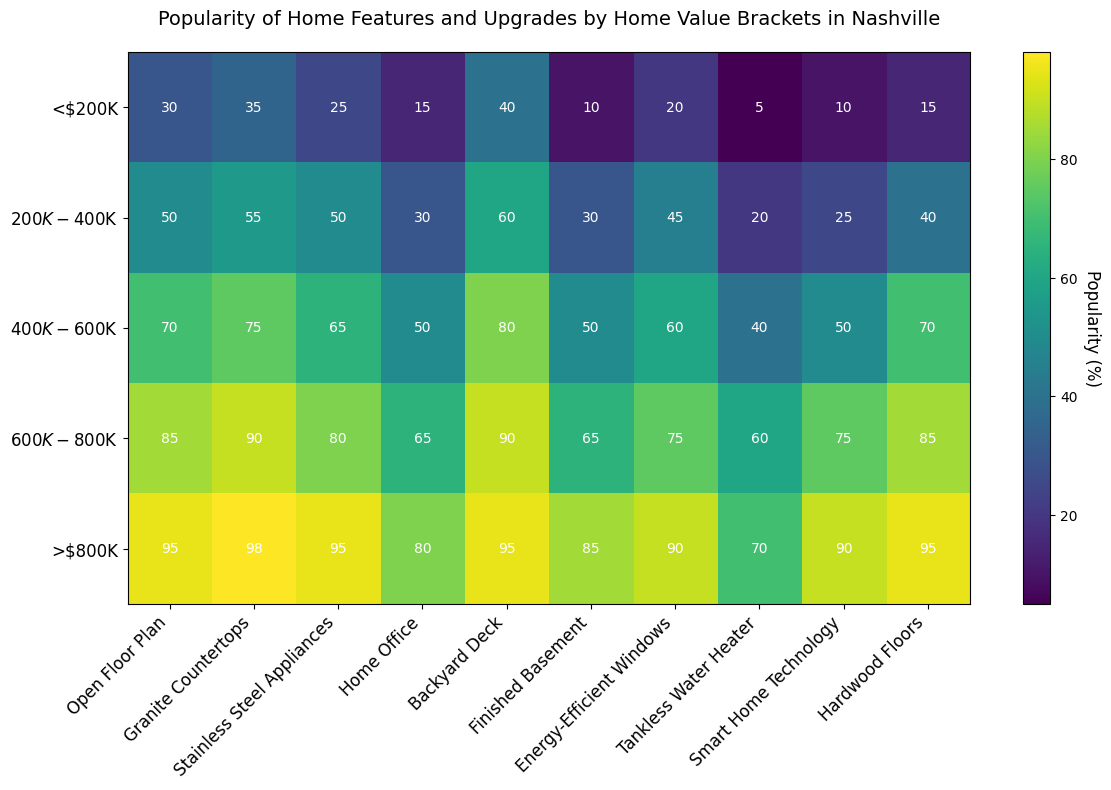Which home feature is most popular in homes valued at above $800K? The popularity values for each feature in the >$800K bracket are shown as percentages. Granite countertops have a value of 98%, which is the highest in this bracket.
Answer: Granite Countertops Which home feature has the least popularity in homes valued at $200K-$400K? Look at the <200K-$400K> row and identify the smallest percentage, which is 20% for Tankless Water Heater.
Answer: Tankless Water Heater What is the average popularity of Energy-Efficient Windows across all home value brackets? Add the percentages for Energy-Efficient Windows (20 + 45 + 60 + 75 + 90) which equals 290, and then divide by 5.
Answer: 58% Is the popularity of Smart Home Technology in the <$200K bracket greater than the popularity of a Home Office in the $200K-$400K bracket? Compare 10% (Smart Home Technology, <$200K>) with 30% (Home Office, $200K-$400K). 10% is less than 30%.
Answer: No Comparing homes in the $400K-$600K and $600K-$800K brackets, which home feature shows the biggest increase in popularity? Subtract the $400K-$600K values from the $600K-$800K values for each feature. The feature with the maximum difference is Smart Home Technology, which increased from 50 to 75, a difference of 25.
Answer: Smart Home Technology Is the popularity of Hardwood Floors in homes valued at >$800K equal to the popularity of Granite Countertops in homes valued at $400K-$600K? Compare 95% (Hardwood Floors, >$800K) with 75% (Granite Countertops, $400K-$600K). Both are equal.
Answer: No How does the popularity of an Open Floor Plan change from <$200K to >$800K? Subtract the percentage for Open Floor Plan in the <$200K bracket (30%) from the percentage in the >$800K bracket (95%). The difference is 65 percentage points.
Answer: Increases by 65 percentage points What is the total popularity of a Finished Basement and Energy-Efficient Windows in homes valued at $600K-$800K? Add the percentages for Finished Basement (65%) and Energy-Efficient Windows (75%) in the $600K-$800K bracket. The total is 140%.
Answer: 140% Does the popularity of Home Offices ever exceed 50% in any bracket? Check each percentage value for Home Office across all brackets. The values are: 15%, 30%, 50%, 65%, 80%. It exceeds 50% in $600K-$800K and >$800K brackets.
Answer: Yes 